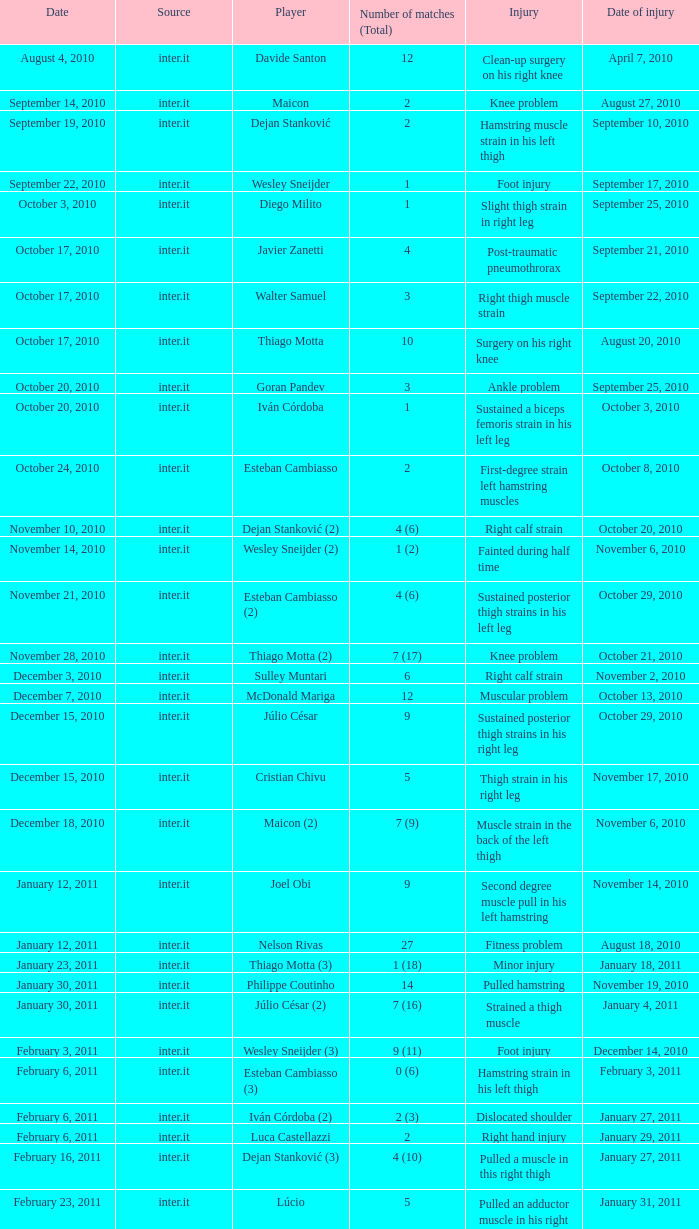What is the date of injury when the injury is sustained posterior thigh strains in his left leg? October 29, 2010. 